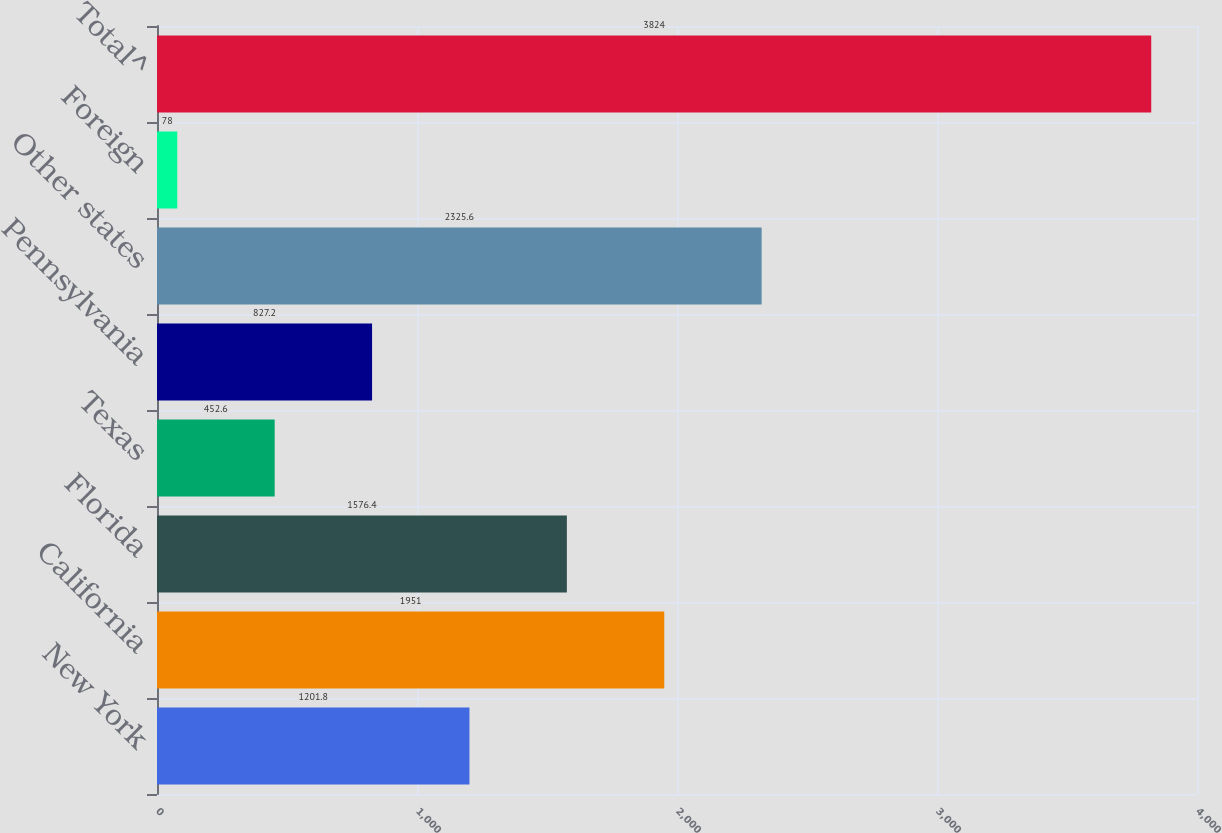<chart> <loc_0><loc_0><loc_500><loc_500><bar_chart><fcel>New York<fcel>California<fcel>Florida<fcel>Texas<fcel>Pennsylvania<fcel>Other states<fcel>Foreign<fcel>Total^<nl><fcel>1201.8<fcel>1951<fcel>1576.4<fcel>452.6<fcel>827.2<fcel>2325.6<fcel>78<fcel>3824<nl></chart> 